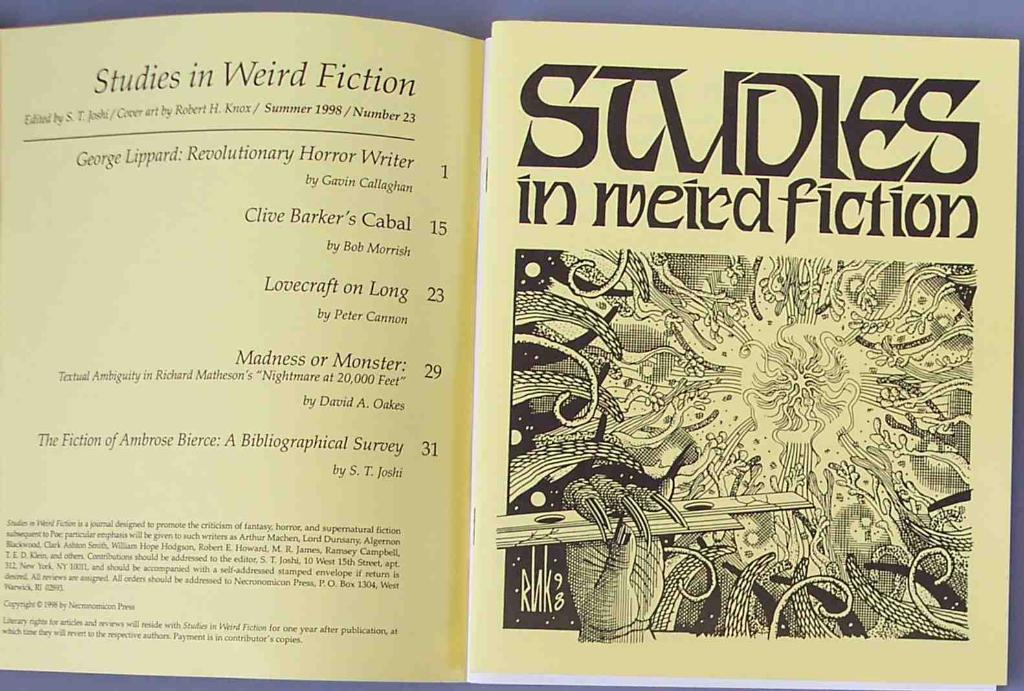<image>
Create a compact narrative representing the image presented. A book that is entitled Studies in Weird Fiction opened to the index page. 